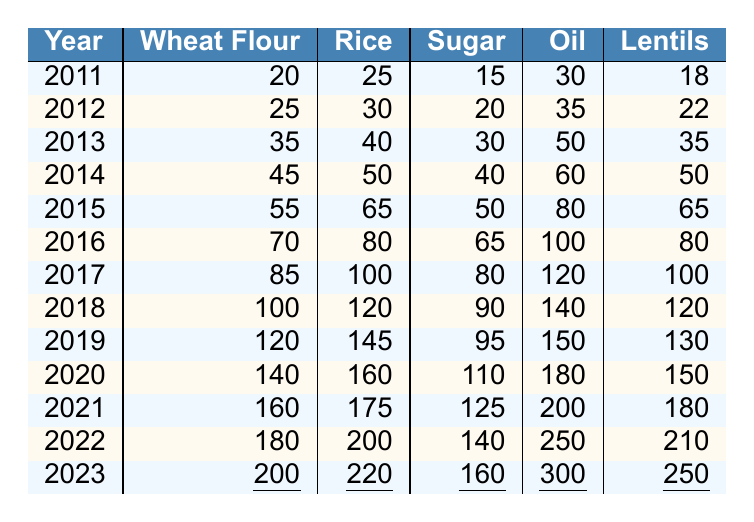What was the price of wheat flour in March 2020? In the row for the year 2020, the price of wheat flour is listed as 140.
Answer: 140 What is the price of sugar in March 2023? In the row for 2023, the price of sugar is shown as 160.
Answer: 160 Which year saw the highest price for oil? Looking across all years in the oil column, the highest price is in 2023, at 300.
Answer: 2023 What is the average price of lentils from 2011 to 2023? To find the average, add all the lentil prices together: (18 + 22 + 35 + 50 + 65 + 80 + 100 + 120 + 130 + 150 + 180 + 210 + 250) =  1390. There are 13 data points, so divide by 13, which equals 107.69, rounded to 108.
Answer: 108 Did the price of rice ever decrease from one year to the next? Noticing the rice prices year by year, it only ever increases; thus, the answer is no.
Answer: No What was the percentage increase in the price of wheat flour from 2011 to 2023? The price in 2011 was 20, and in 2023 it is 200. The increase is 200 - 20 = 180. To find the percentage increase: (180/20) * 100 = 900%.
Answer: 900% What is the difference in the price of sugar between 2011 and 2023? The price of sugar in 2011 was 15, and in 2023, it was 160. The difference is 160 - 15 = 145.
Answer: 145 How much did the price of oil rise from March 2019 to March 2022? The price of oil in March 2019 was 150, and in March 2022 it was 250. The rise is calculated as 250 - 150 = 100.
Answer: 100 In which year did lentils cost 100 or more? By checking the lentils row, it shows that lentils reached 100 in the year 2017.
Answer: 2017 Is the price of rice always higher than the price of sugar from 2011 to 2023? Comparing the rice and sugar prices across the years, rice prices are always higher than sugar prices, so the answer is yes.
Answer: Yes 